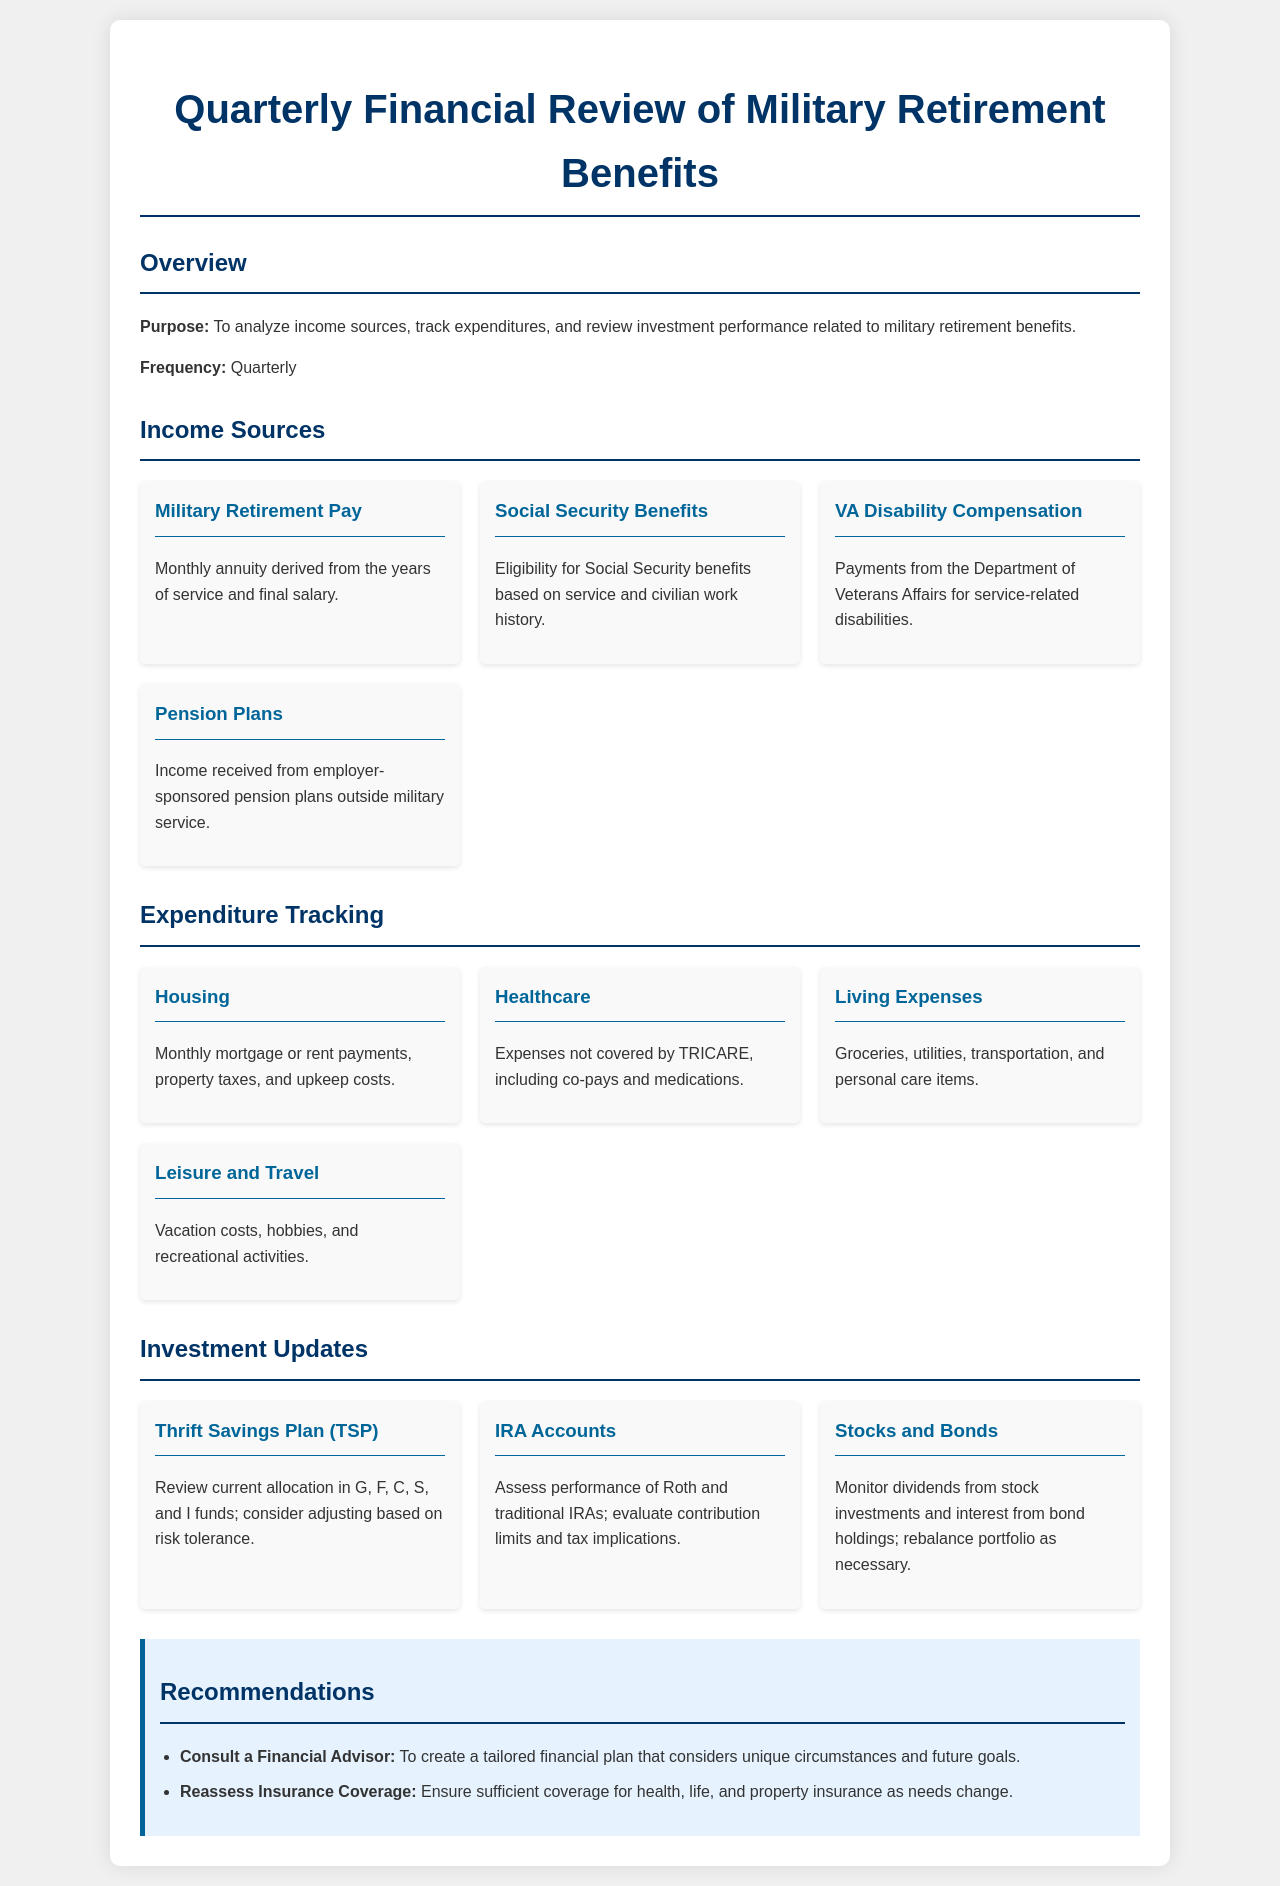What is the purpose of the document? The purpose of the document is to analyze income sources, track expenditures, and review investment performance related to military retirement benefits.
Answer: To analyze income sources, track expenditures, and review investment performance related to military retirement benefits How often is the financial review conducted? The document states the frequency of the review.
Answer: Quarterly What are two sources of income mentioned? The sources mentioned in the income section include military retirement pay, Social Security benefits, VA disability compensation, and pension plans.
Answer: Military Retirement Pay, Social Security Benefits What are the main categories of expenditures tracked? The expenditure tracking section includes housing, healthcare, living expenses, and leisure and travel as main categories.
Answer: Housing, Healthcare, Living Expenses, Leisure and Travel Which investment plan is reviewed in the document? The document lists specific investment updates that include the Thrift Savings Plan.
Answer: Thrift Savings Plan (TSP) What is a recommendation made in the document? The recommendations list suggests consulting a financial advisor and reassessing insurance coverage.
Answer: Consult a Financial Advisor What type of insurance coverage should be reassessed? Insurance coverage is mentioned specifically in the recommendations section as needing reassessment.
Answer: Health, life, and property insurance What does TSP stand for? TSP is an acronym mentioned for the Thrift Savings Plan in the investment updates.
Answer: Thrift Savings Plan What type of expenses does the healthcare category include? The healthcare expenditure category includes costs like co-pays and medications not covered by TRICARE.
Answer: Expenses not covered by TRICARE, including co-pays and medications 